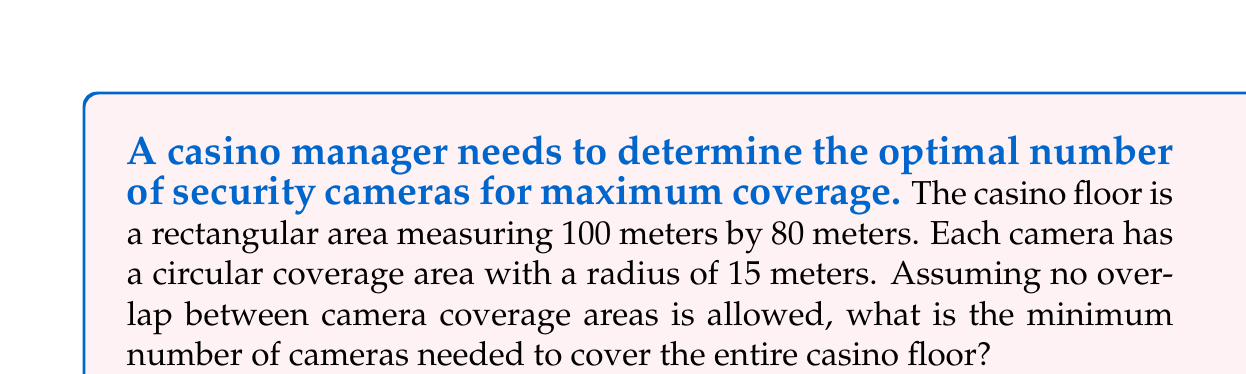Give your solution to this math problem. To solve this problem, we'll follow these steps:

1. Calculate the area of the casino floor:
   $$A_{casino} = 100 \text{ m} \times 80 \text{ m} = 8000 \text{ m}^2$$

2. Calculate the area covered by each camera:
   $$A_{camera} = \pi r^2 = \pi (15 \text{ m})^2 = 225\pi \text{ m}^2$$

3. Calculate the number of cameras needed:
   $$N_{cameras} = \left\lceil\frac{A_{casino}}{A_{camera}}\right\rceil$$

   Where $\lceil \rceil$ denotes the ceiling function (rounding up to the nearest integer).

4. Substitute the values:
   $$N_{cameras} = \left\lceil\frac{8000 \text{ m}^2}{225\pi \text{ m}^2}\right\rceil$$

5. Evaluate:
   $$N_{cameras} = \left\lceil\frac{8000}{225\pi}\right\rceil \approx \left\lceil 11.338 \right\rceil = 12$$

Therefore, the minimum number of cameras needed to cover the entire casino floor without overlap is 12.

[asy]
size(200);
draw((0,0)--(100,0)--(100,80)--(0,80)--cycle);
for(int i = 0; i < 4; ++i) {
  for(int j = 0; j < 3; ++j) {
    draw(circle((25+i*50,26.67+j*26.67),15));
  }
}
label("Casino Floor (100m x 80m)", (50,90));
label("Camera Coverage", (50,-10));
[/asy]
Answer: 12 cameras 